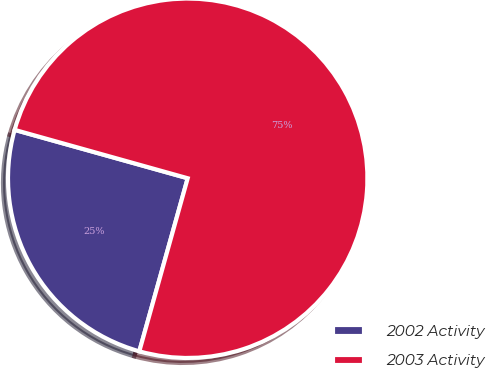Convert chart to OTSL. <chart><loc_0><loc_0><loc_500><loc_500><pie_chart><fcel>2002 Activity<fcel>2003 Activity<nl><fcel>25.0%<fcel>75.0%<nl></chart> 